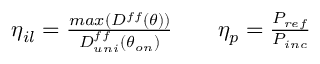Convert formula to latex. <formula><loc_0><loc_0><loc_500><loc_500>\begin{array} { r l r } { \eta _ { i l } = \frac { \max ( D ^ { f f } ( \theta ) ) } { D _ { u n i } ^ { f f } ( \theta _ { o n } ) } } & { \eta _ { p } = \frac { P _ { r e f } } { P _ { i n c } } } \end{array}</formula> 